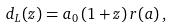Convert formula to latex. <formula><loc_0><loc_0><loc_500><loc_500>d _ { L } ( z ) = a _ { 0 } \, ( 1 + z ) \, r ( a ) \, ,</formula> 